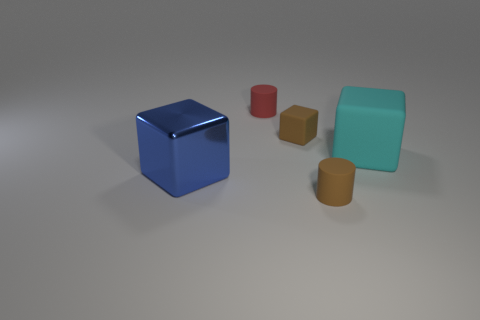Add 1 blue metallic cubes. How many objects exist? 6 Subtract all blocks. How many objects are left? 2 Subtract all tiny blue metal objects. Subtract all brown cylinders. How many objects are left? 4 Add 5 big cyan matte objects. How many big cyan matte objects are left? 6 Add 3 blue metallic cubes. How many blue metallic cubes exist? 4 Subtract 1 blue blocks. How many objects are left? 4 